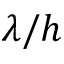<formula> <loc_0><loc_0><loc_500><loc_500>\lambda / h</formula> 